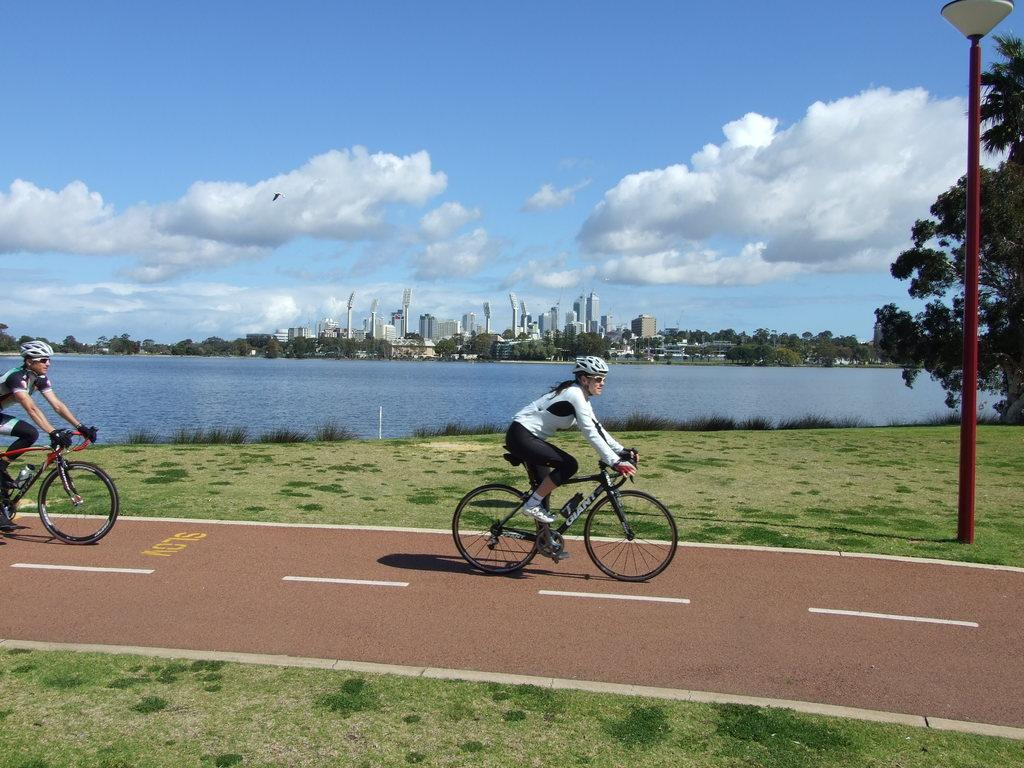What are the two persons in the image doing? The two persons in the image are riding bicycles. What type of terrain can be seen in the image? A: There is grass in the image. What object is present in the image that might be used for support or guidance? There is a pole in the image. What type of illumination is visible in the image? There is a light in the image. What type of water feature can be seen in the image? There is water visible in the image. What type of vegetation is present in the image? There are plants and trees in the image. What type of man-made structures can be seen in the image? There are buildings in the image. What is visible in the background of the image? The sky is visible in the background of the image. What type of beef is being prepared in the image? There is no beef present in the image. 